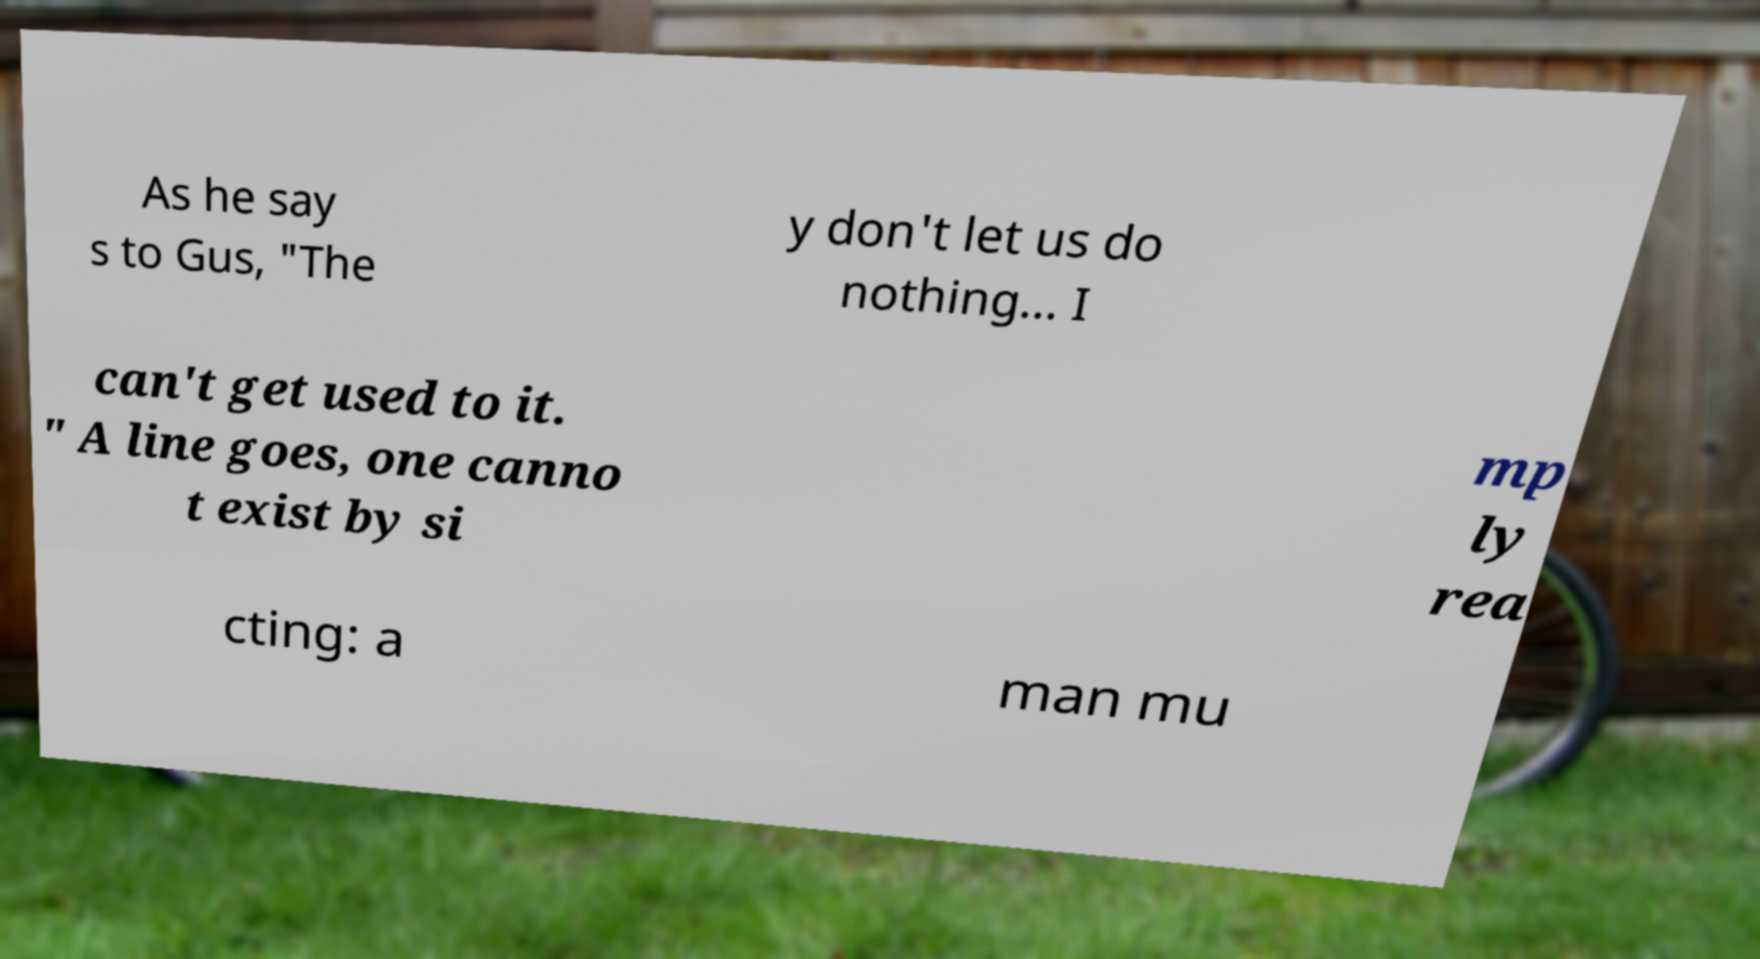I need the written content from this picture converted into text. Can you do that? As he say s to Gus, "The y don't let us do nothing... I can't get used to it. " A line goes, one canno t exist by si mp ly rea cting: a man mu 